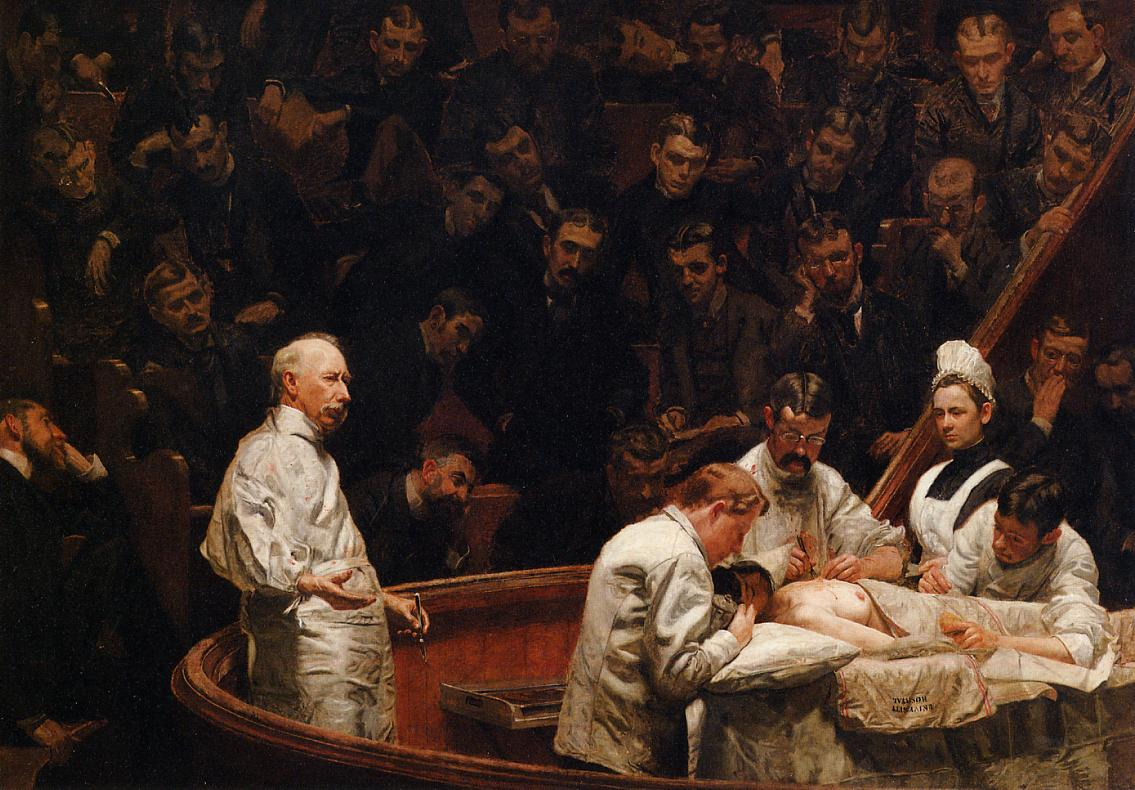What can we infer about the historical context of the image? The image suggests a historical context where public surgical demonstrations were common in medical education. The attire of the surgeons and the presence of many observers imply a time before modern technology, possibly the 19th century. The lighting and dark hues convey a somber mood, reflecting the seriousness of early surgical procedures which were high-risk and performed without modern anesthesia or antiseptic techniques. The gathered crowd of medical students indicates the educational importance of such operations in the historical development of surgical practices. Why are the students and other onlookers so closely packed together? The close packing of students and onlookers suggests the high interest and educational value of the surgical procedure being demonstrated. This reflects a period when such operations were used as teaching moments for medical students, who would learn by observing experienced surgeons. The crowding also highlights the lack of modern technology like video recordings that today's medical students might use for learning. Thus, witnessing an operation firsthand was essential for their education. Imagine the thoughts running through the patient's mind before the operation began. The patient, lying on the table, might be experiencing a mix of fear, anxiety, and hope. Knowing the risks involved in surgery during this time period, without modern anesthesia or antiseptics, the patient’s mind could be filled with apprehension. They may ponder the skill of the surgeons, hope for a successful outcome, and fear the pain and potential complications. The presence of a public audience might add to the stress, knowing many eyes are upon them during such a vulnerable moment. If this scene were to be reenacted today with modern technology, what differences might we see? A modern reenactment would showcase numerous advancements in surgical techniques and medical technology. The surgeons would likely be using advanced instruments, and the patient would be under general anesthesia, significantly reducing pain and awareness. The operating room would be sterile, with fewer onlookers present physically; instead, students might watch the procedure via live video feed. The presence of modern monitoring equipment and the use of scrubs, masks, and gloves would starkly contrast with the historical scene. The ambiance would be brighter and more clinical, with a greater emphasis on hygiene and patient safety. 